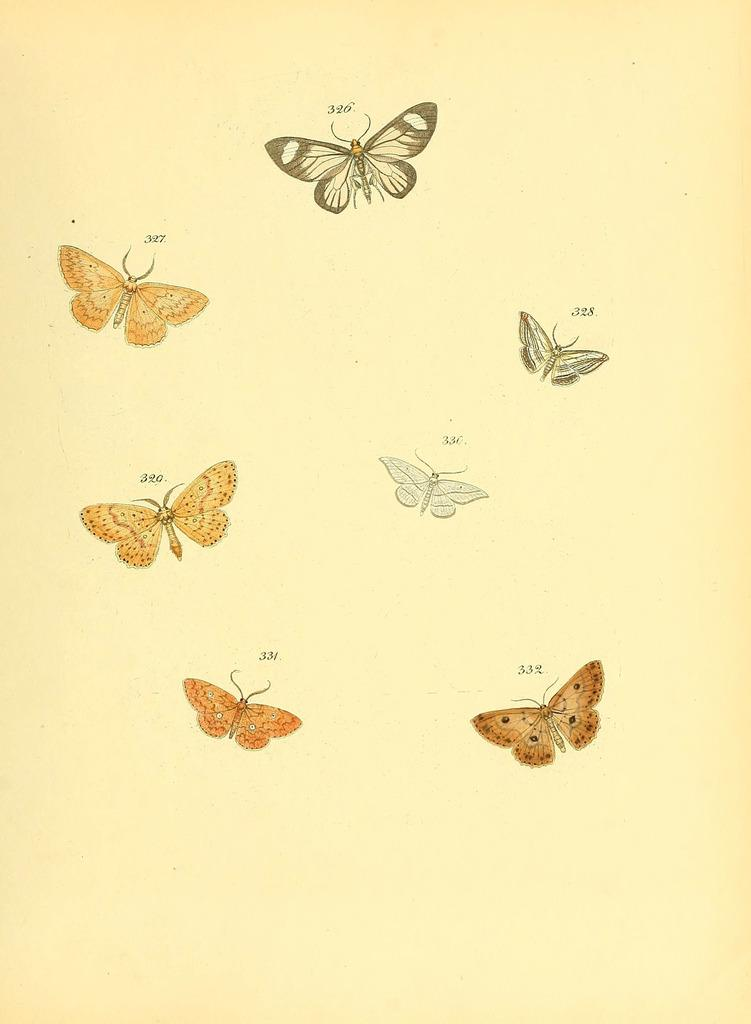What is depicted in the sketches in the image? There are sketches of butterflies in the image. What is the medium for the sketches? The sketches are on a paper. Can you hear any music playing in the background of the image? There is no indication of music or any sound in the image, as it only features sketches of butterflies on a paper. 